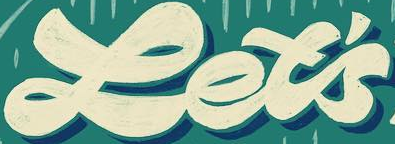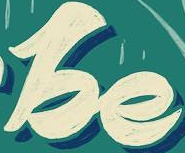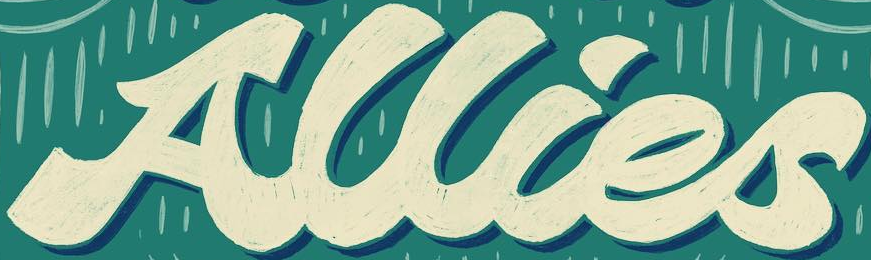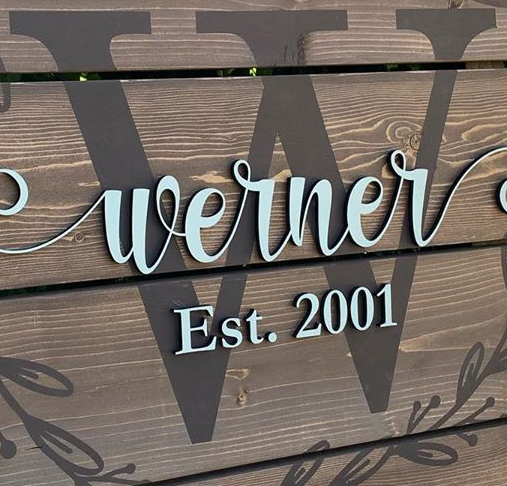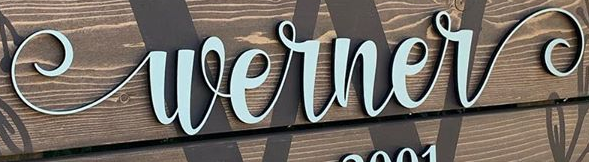Read the text content from these images in order, separated by a semicolon. Let's; be; Allies; W; Werner 